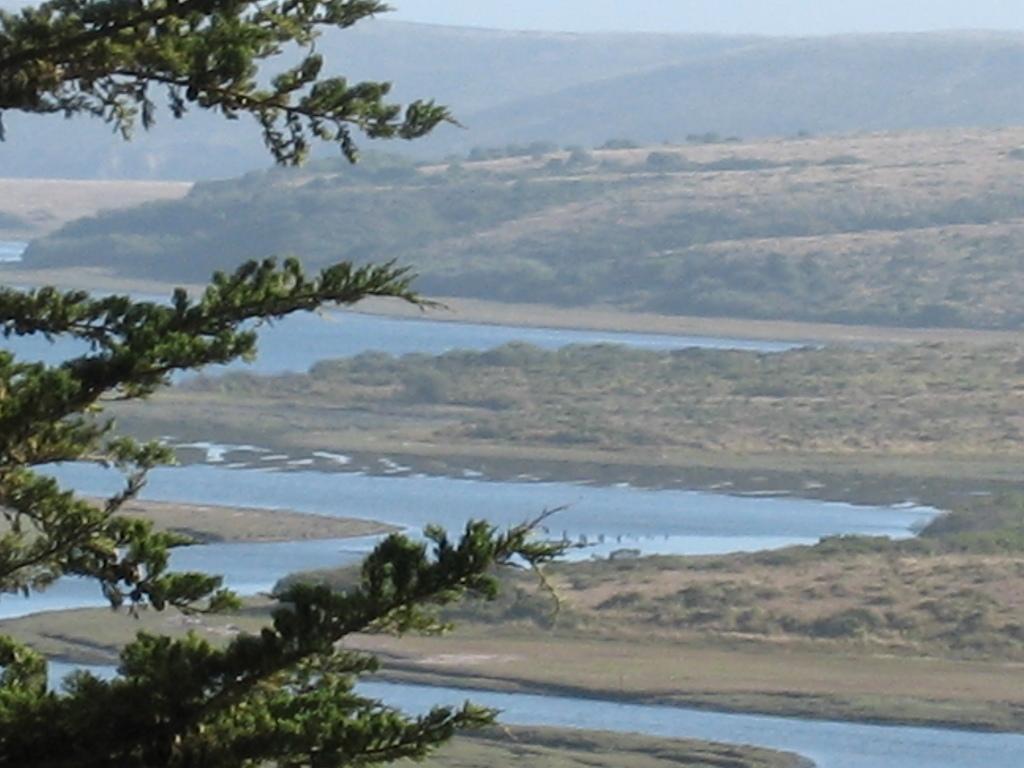In one or two sentences, can you explain what this image depicts? In this image in front there is a tree. At the bottom there is water. In the background there are trees, mountains and sky. 